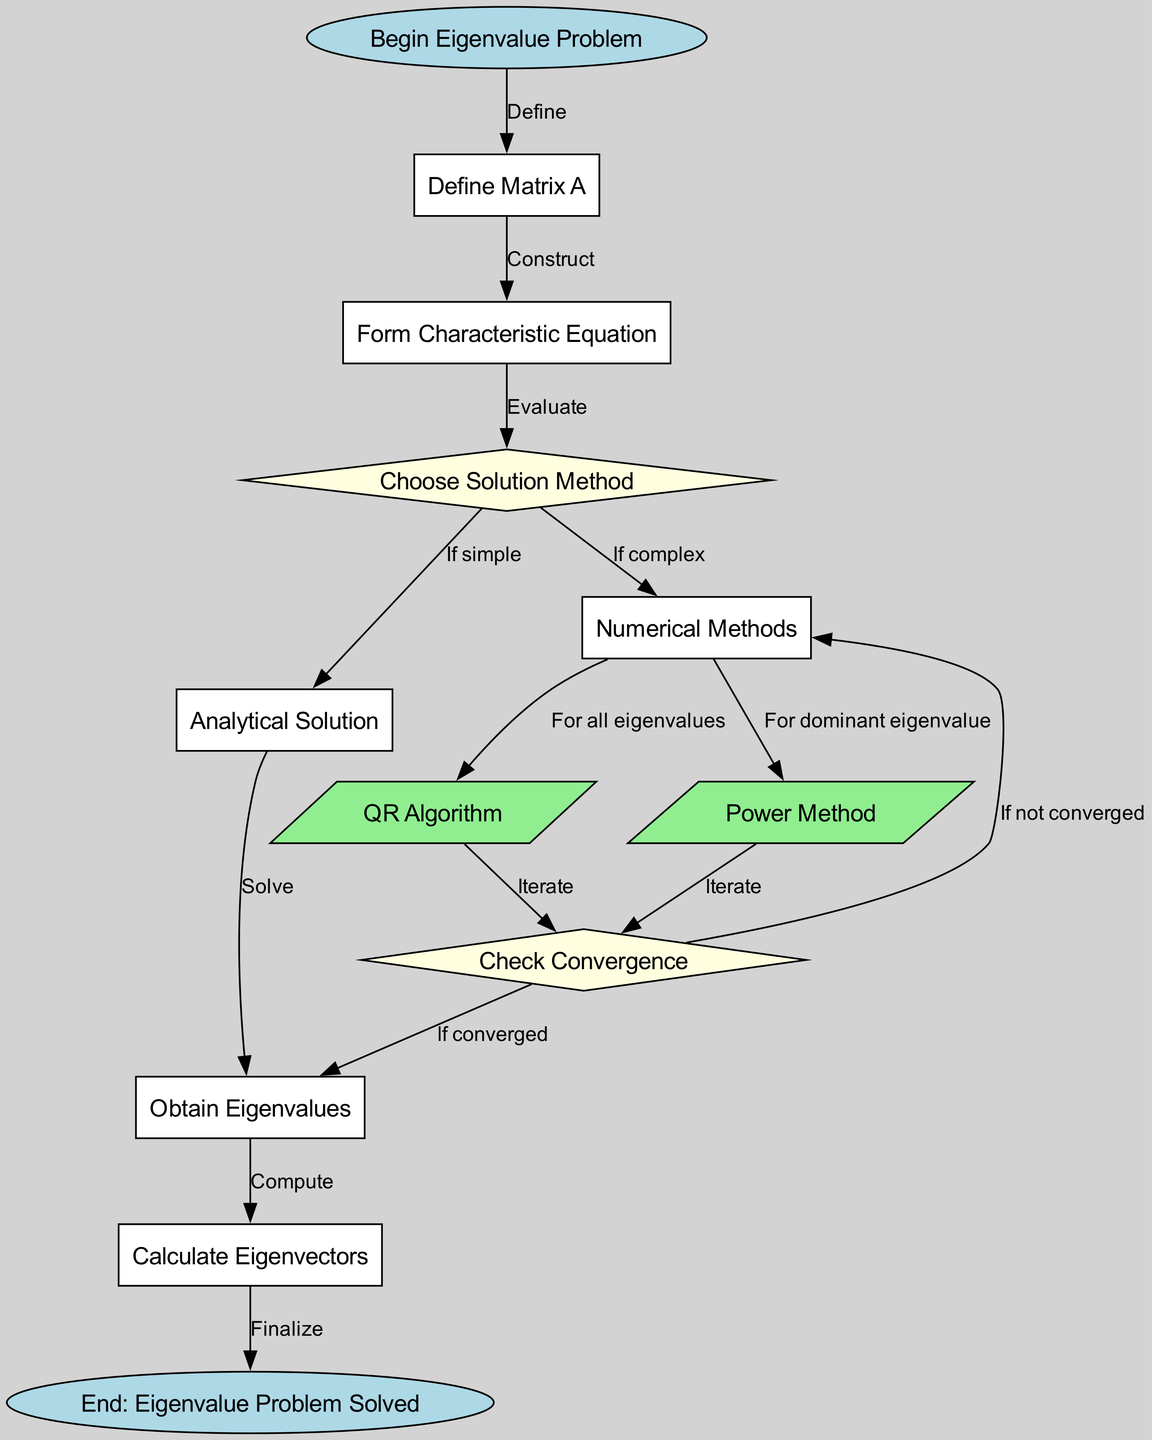What is the first step in the process? The first node in the flowchart is labeled "Begin Eigenvalue Problem", which indicates this is where the process starts.
Answer: Begin Eigenvalue Problem How many nodes are there in total? By counting all the nodes listed in the diagram's data, I find there are a total of 13 nodes.
Answer: 13 What is the label of the node that represents the convergence check? The node that represents the convergence check is labeled "Check Convergence". This is indicated by the diamond-shaped node that follows the numerical methods.
Answer: Check Convergence What method is chosen if the problem is complex? The flowchart states that if the problem is complex, the "Numerical Methods" node is chosen as the solution approach, which is clearly stated in the diagram's paths.
Answer: Numerical Methods What happens if the QR algorithm converges? If the QR algorithm converges, the flowchart directs to the node labeled "Obtain Eigenvalues", indicating that this is the next step after convergence.
Answer: Obtain Eigenvalues What are the two paths after choosing a solution method? After deciding on a solution method, the flowchart splits into two paths: one leading to "Analytical Solution" if the problem is simple, and the other leading to "Numerical Methods" if the problem is complex.
Answer: Analytical Solution and Numerical Methods What process follows the calculation of eigenvalues? Once the eigenvalues are obtained, the next step is to "Calculate Eigenvectors", as shown in the subsequent node connected to the eigenvalues node.
Answer: Calculate Eigenvectors What type of diagram is this? This diagram is a flowchart, as it depicts a step-by-step process with nodes and edges showing the transitions between steps and decisions.
Answer: Flowchart 